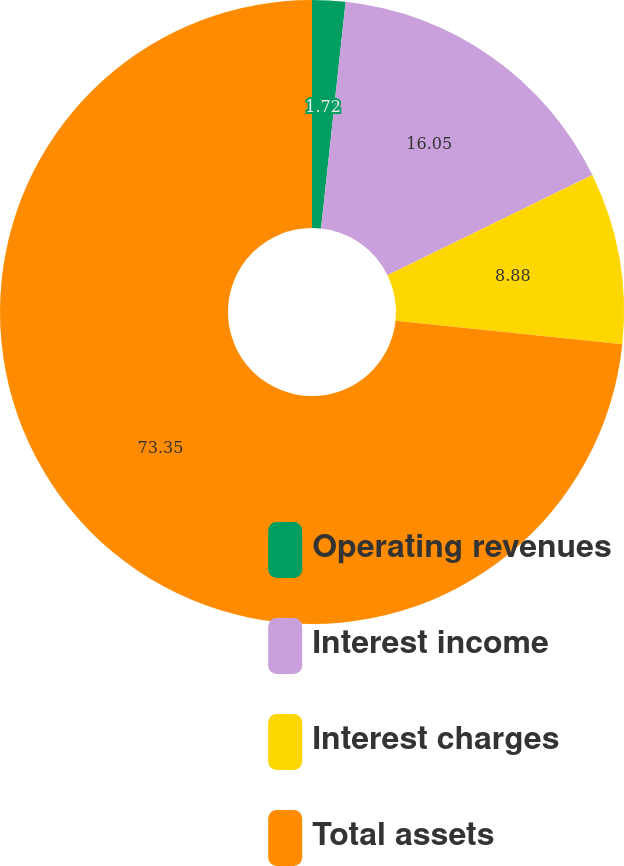<chart> <loc_0><loc_0><loc_500><loc_500><pie_chart><fcel>Operating revenues<fcel>Interest income<fcel>Interest charges<fcel>Total assets<nl><fcel>1.72%<fcel>16.05%<fcel>8.88%<fcel>73.35%<nl></chart> 